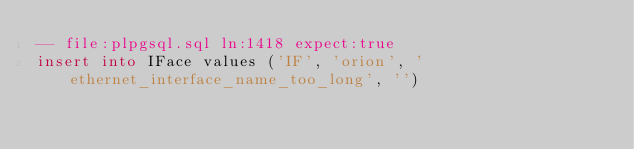<code> <loc_0><loc_0><loc_500><loc_500><_SQL_>-- file:plpgsql.sql ln:1418 expect:true
insert into IFace values ('IF', 'orion', 'ethernet_interface_name_too_long', '')
</code> 